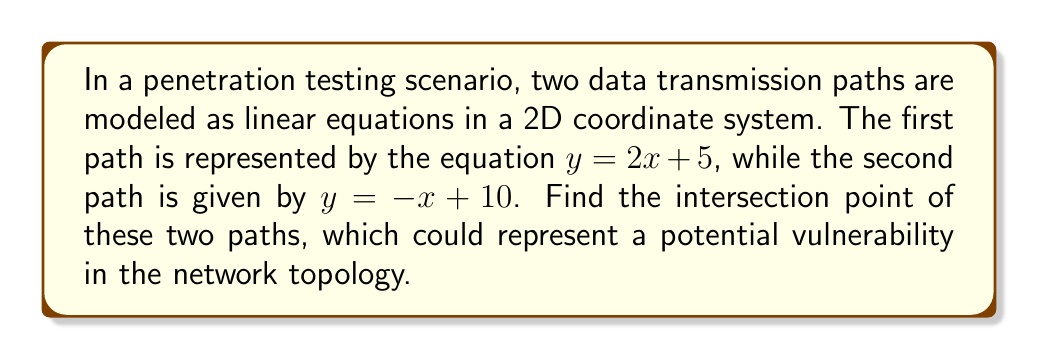Give your solution to this math problem. To find the intersection point of two lines, we need to solve the system of equations:

$$\begin{cases}
y = 2x + 5 \\
y = -x + 10
\end{cases}$$

Step 1: Since both equations are equal to $y$, we can set them equal to each other:
$$2x + 5 = -x + 10$$

Step 2: Solve for $x$:
$$2x + x = 10 - 5$$
$$3x = 5$$
$$x = \frac{5}{3}$$

Step 3: Substitute this $x$ value into either of the original equations. Let's use $y = 2x + 5$:
$$y = 2(\frac{5}{3}) + 5$$
$$y = \frac{10}{3} + 5$$
$$y = \frac{10}{3} + \frac{15}{3}$$
$$y = \frac{25}{3}$$

Therefore, the intersection point is $(\frac{5}{3}, \frac{25}{3})$.

[asy]
unitsize(1cm);
defaultpen(fontsize(10pt));

// Draw axes
draw((-1,0)--(5,0), arrow=Arrow(TeXHead));
draw((0,-1)--(0,10), arrow=Arrow(TeXHead));

// Draw lines
draw((0,5)--(3,11), blue, Arrows(TeXHead));
draw((0,10)--(5,5), red, Arrows(TeXHead));

// Label lines
label("$y = 2x + 5$", (2.5,10), blue, NE);
label("$y = -x + 10$", (4,6), red, SE);

// Mark intersection point
dot((5/3, 25/3), purple);
label("$(\frac{5}{3}, \frac{25}{3})$", (5/3, 25/3), purple, NE);

// Label axes
label("$x$", (5,0), S);
label("$y$", (0,10), W);
[/asy]
Answer: The intersection point of the two data transmission paths is $(\frac{5}{3}, \frac{25}{3})$. 